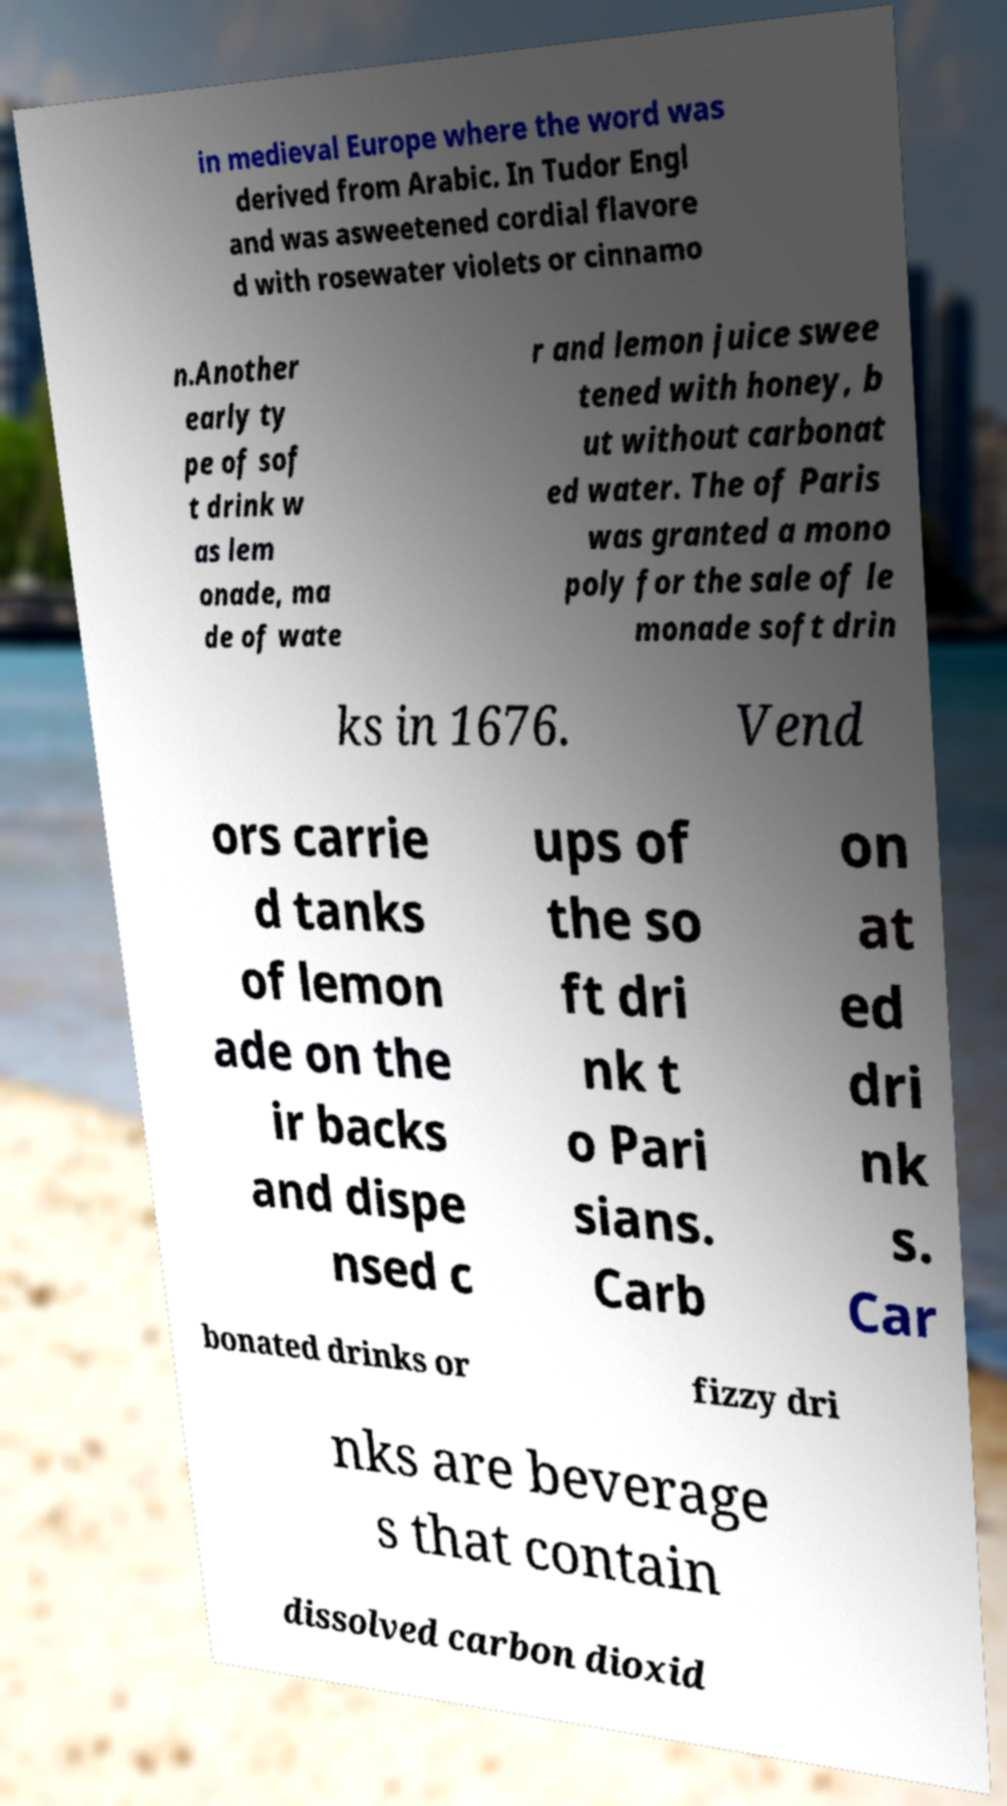What messages or text are displayed in this image? I need them in a readable, typed format. in medieval Europe where the word was derived from Arabic. In Tudor Engl and was asweetened cordial flavore d with rosewater violets or cinnamo n.Another early ty pe of sof t drink w as lem onade, ma de of wate r and lemon juice swee tened with honey, b ut without carbonat ed water. The of Paris was granted a mono poly for the sale of le monade soft drin ks in 1676. Vend ors carrie d tanks of lemon ade on the ir backs and dispe nsed c ups of the so ft dri nk t o Pari sians. Carb on at ed dri nk s. Car bonated drinks or fizzy dri nks are beverage s that contain dissolved carbon dioxid 